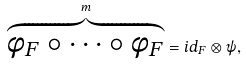Convert formula to latex. <formula><loc_0><loc_0><loc_500><loc_500>\overbrace { \phi _ { F } \circ \cdots \circ \phi _ { F } } ^ { m } = i d _ { F } \otimes \psi ,</formula> 